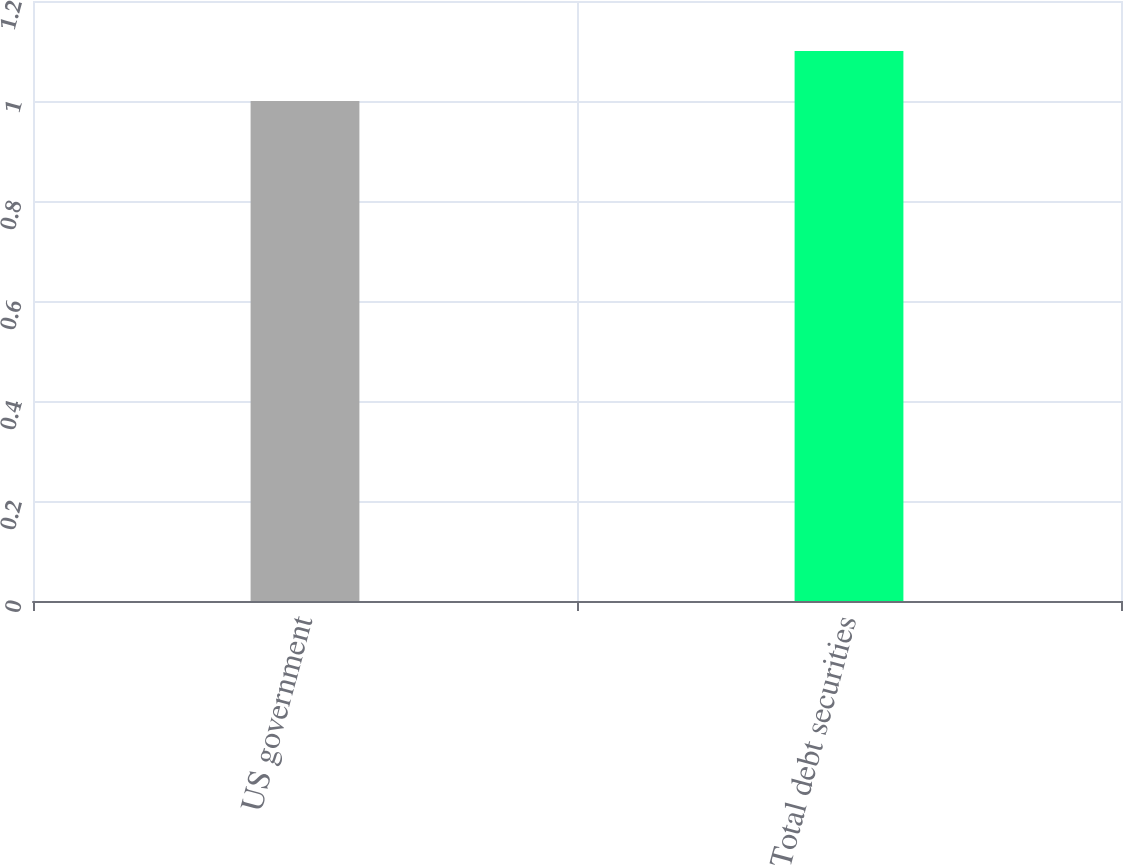Convert chart to OTSL. <chart><loc_0><loc_0><loc_500><loc_500><bar_chart><fcel>US government<fcel>Total debt securities<nl><fcel>1<fcel>1.1<nl></chart> 